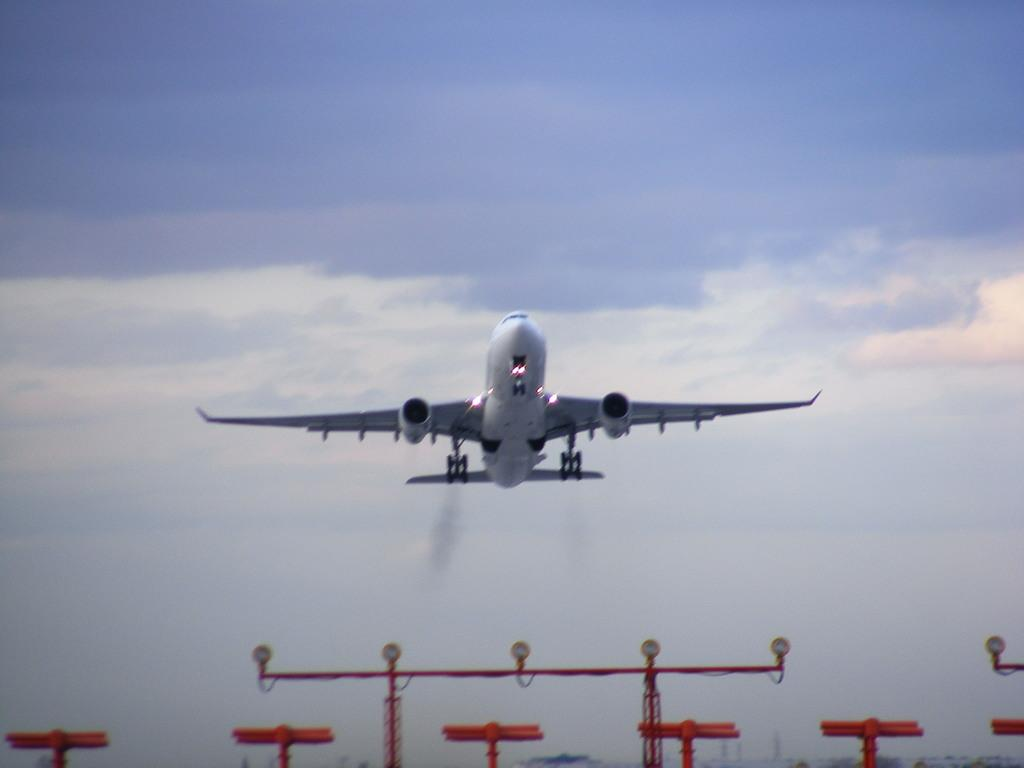What is the main subject in the center of the image? There is an aeroplane in the center of the image. What can be seen at the bottom of the image? There are towers and lights at the bottom of the image. What is visible in the sky in the background of the image? Clouds are present in the sky in the background of the image. What type of winter clothing is being worn by the astronauts in the image? There are no astronauts or winter clothing present in the image; it features an aeroplane, towers, lights, and clouds. 